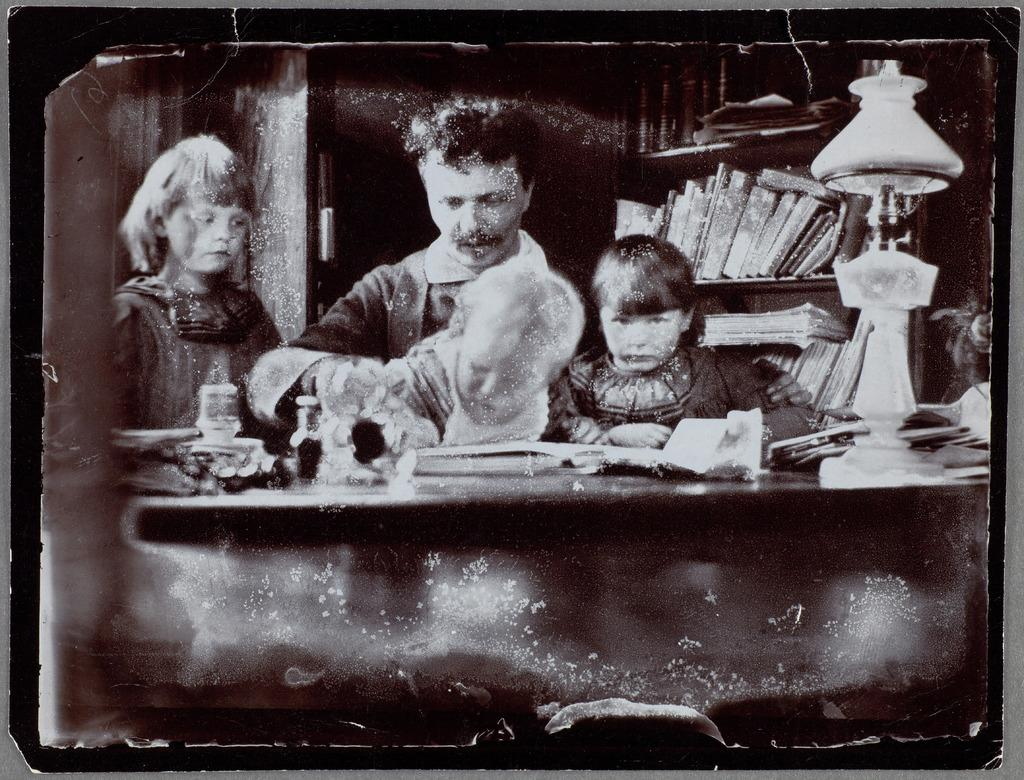What type of object is in the image? There is an old photograph in the image. Who is in the photograph? The photograph contains a man and three children. What are the people in the photograph wearing? The people in the photograph are wearing clothes. What other objects can be seen in the image? There is a lamp and books on shelves in the image. What type of veil is the man wearing in the image? There is no veil visible in the image, as it is an old photograph of people wearing clothes, but no specific headwear is mentioned. 